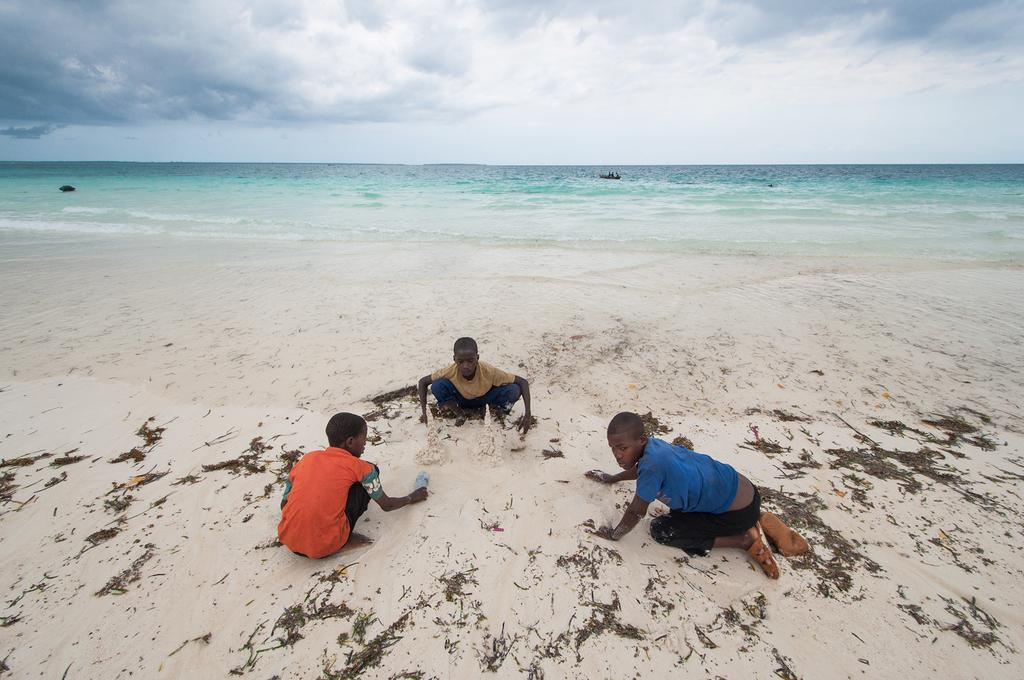How many people are in the image? There are three persons in the image. Where are the persons located? The persons are on a sandy area. What is one person holding in the image? One person is holding a bottle. What can be seen in the background of the image? There is water and the sky visible in the background of the image. What type of brake can be seen on the person's foot in the image? There is no brake visible on any person's foot in the image. How do the ants react to the presence of the persons in the image? There are no ants present in the image, so their reaction cannot be observed. 